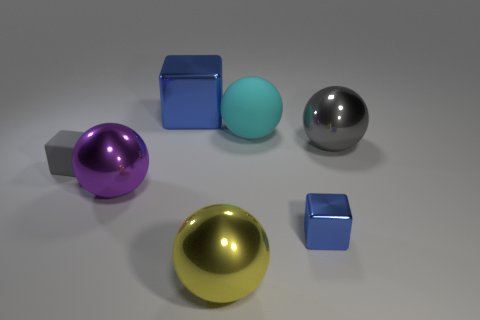Subtract all red spheres. How many blue cubes are left? 2 Subtract all tiny matte blocks. How many blocks are left? 2 Subtract all yellow spheres. How many spheres are left? 3 Subtract 1 balls. How many balls are left? 3 Subtract all spheres. How many objects are left? 3 Add 1 large brown shiny cylinders. How many objects exist? 8 Subtract all brown spheres. Subtract all brown cylinders. How many spheres are left? 4 Add 6 gray cubes. How many gray cubes exist? 7 Subtract 0 yellow blocks. How many objects are left? 7 Subtract all small metallic things. Subtract all large matte balls. How many objects are left? 5 